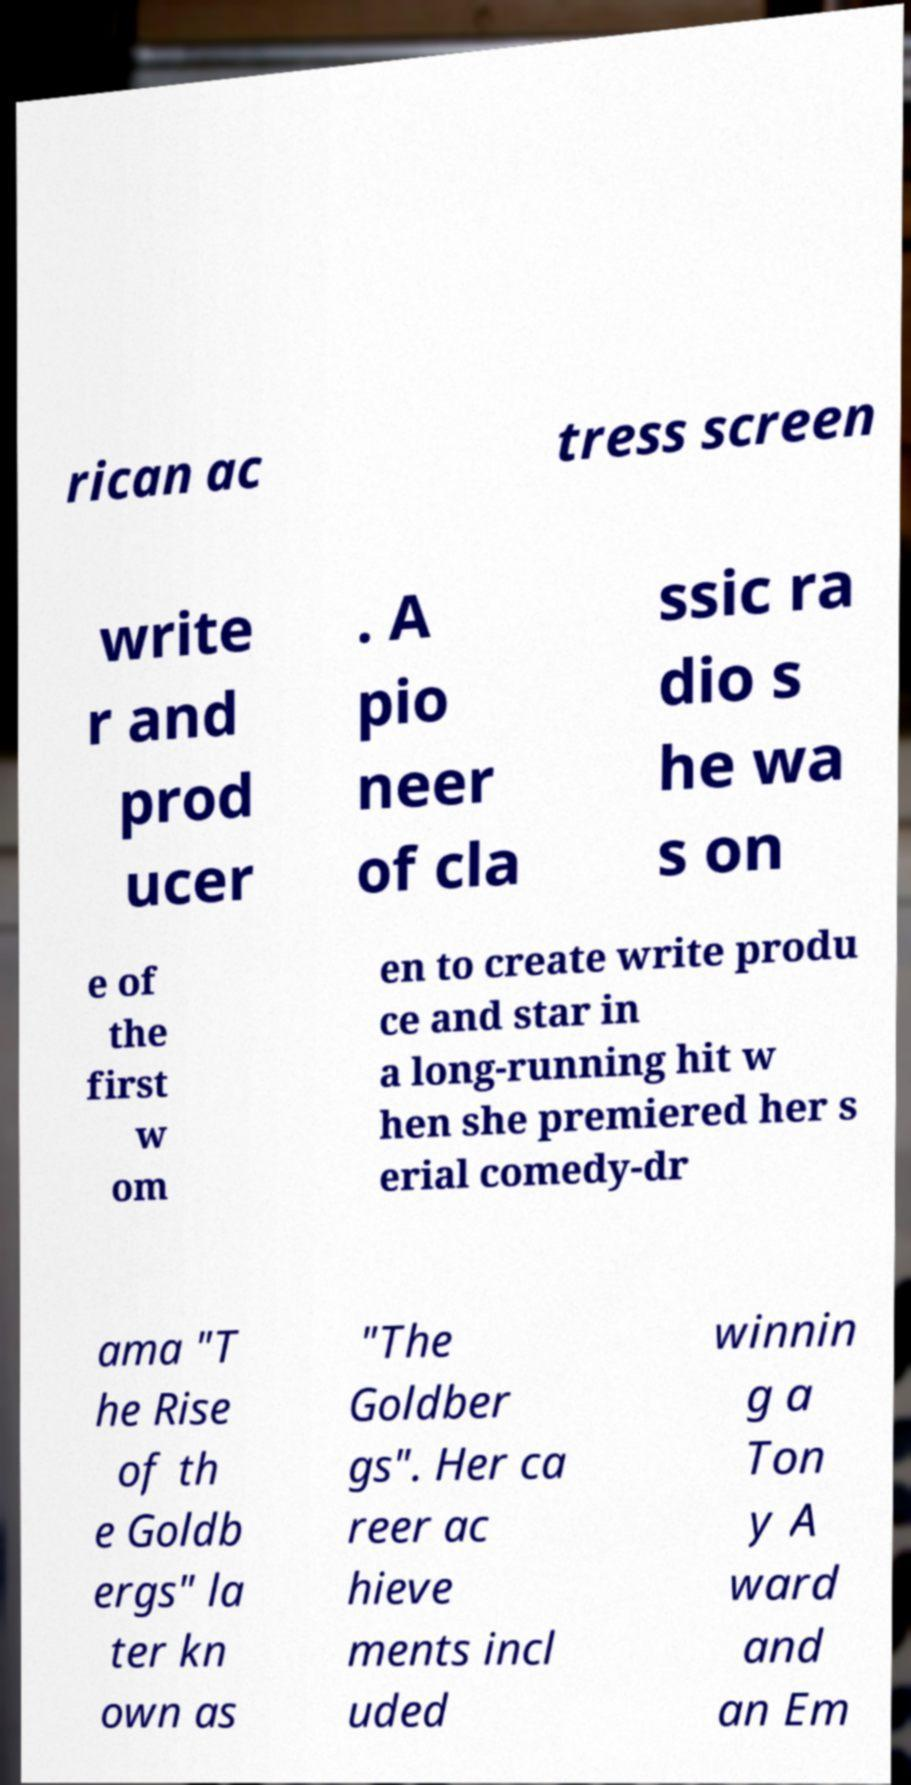I need the written content from this picture converted into text. Can you do that? rican ac tress screen write r and prod ucer . A pio neer of cla ssic ra dio s he wa s on e of the first w om en to create write produ ce and star in a long-running hit w hen she premiered her s erial comedy-dr ama "T he Rise of th e Goldb ergs" la ter kn own as "The Goldber gs". Her ca reer ac hieve ments incl uded winnin g a Ton y A ward and an Em 